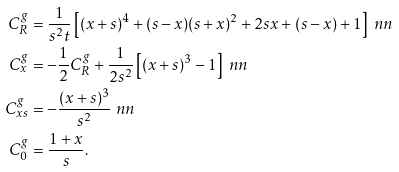<formula> <loc_0><loc_0><loc_500><loc_500>C ^ { g } _ { R } & = \frac { 1 } { s ^ { 2 } t } \left [ ( x + s ) ^ { 4 } + ( s - x ) ( s + x ) ^ { 2 } + 2 s x + ( s - x ) + 1 \right ] \ n n \\ C ^ { g } _ { x } & = - \frac { 1 } { 2 } C ^ { g } _ { R } + \frac { 1 } { 2 s ^ { 2 } } \left [ ( x + s ) ^ { 3 } - 1 \right ] \ n n \\ C ^ { g } _ { x s } & = - \frac { ( x + s ) ^ { 3 } } { s ^ { 2 } } \ n n \\ C ^ { g } _ { 0 } & = \frac { 1 + x } { s } .</formula> 